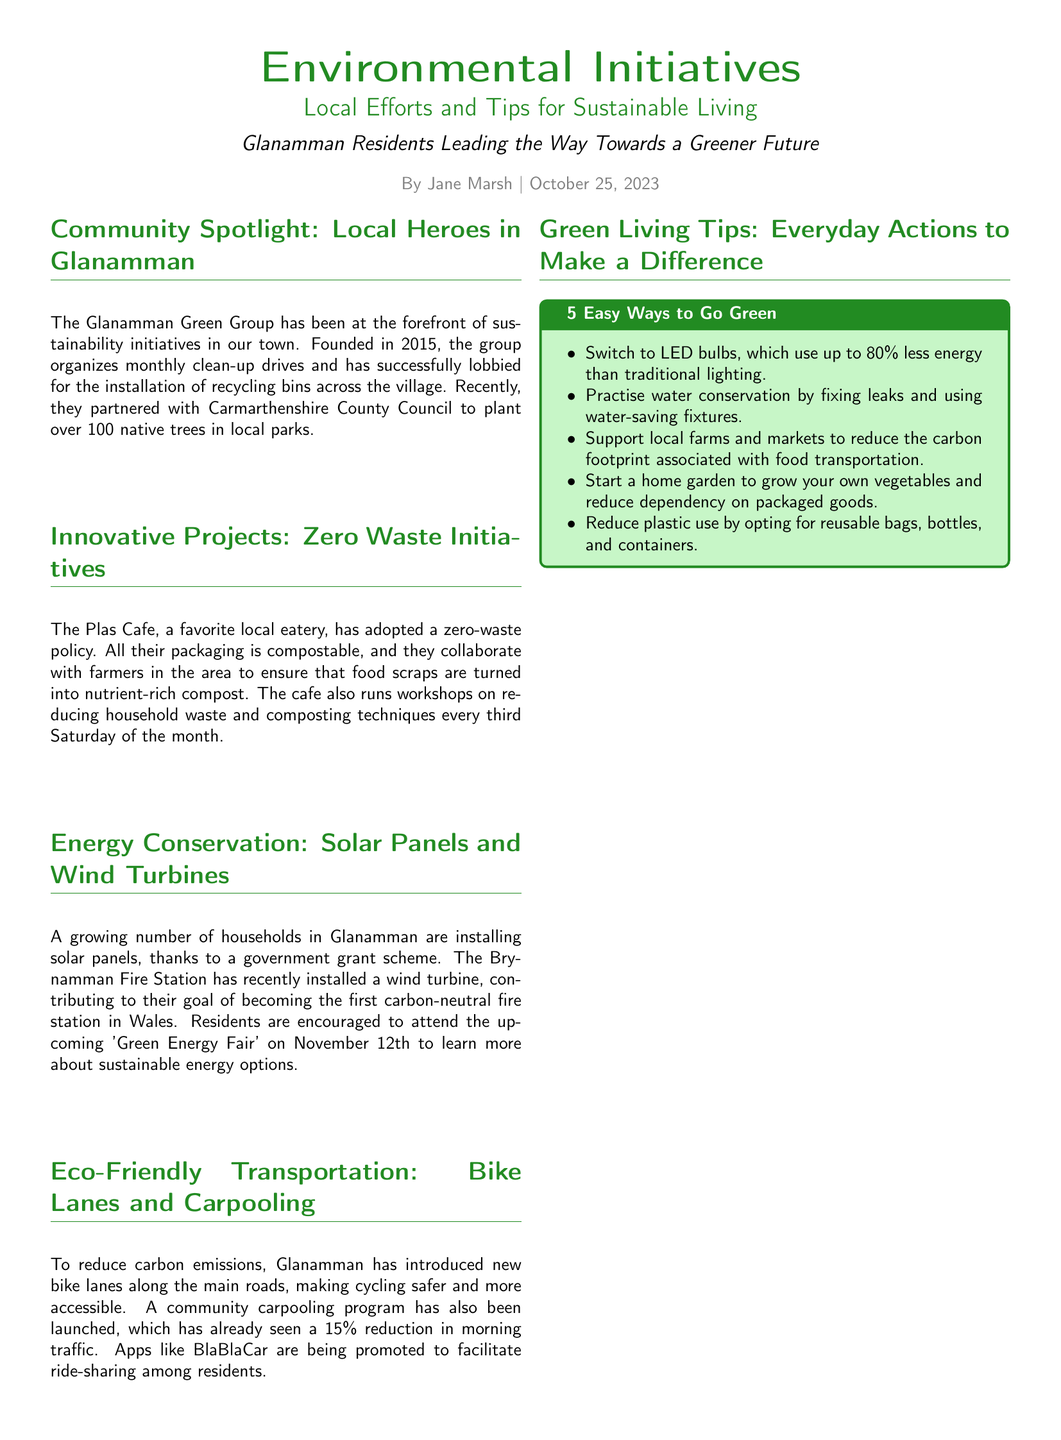What is the name of the local group leading sustainability initiatives? The local group leading sustainability initiatives is called the Glanamman Green Group.
Answer: Glanamman Green Group When was the Glanamman Green Group founded? The document states that the Glanamman Green Group was founded in 2015.
Answer: 2015 How many native trees did the Glanamman Green Group help plant? The document reports that over 100 native trees were planted in local parks by the group.
Answer: over 100 What is the goal of the Brynamman Fire Station? According to the document, the goal of the Brynamman Fire Station is to become the first carbon-neutral fire station in Wales.
Answer: first carbon-neutral fire station in Wales What percentage reduction in morning traffic has the carpooling program achieved? The document indicates that the carpooling program has achieved a 15% reduction in morning traffic.
Answer: 15% What is the date of the Green Energy Fair? The document mentions that the Green Energy Fair is scheduled for November 12th, 2023.
Answer: November 12th, 2023 What is one of the tips provided for going green? The document lists switching to LED bulbs as one of the tips for going green.
Answer: Switch to LED bulbs What time does the Glanamman Green Group meet? The document states that the Glanamman Green Group meets at 7 PM.
Answer: 7 PM What color is used for the section titles in the document? The section titles in the document are colored forest green.
Answer: forest green 